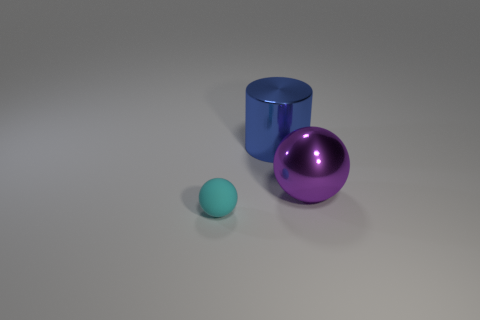Add 1 small matte objects. How many objects exist? 4 Subtract all spheres. How many objects are left? 1 Add 2 small spheres. How many small spheres exist? 3 Subtract 0 blue cubes. How many objects are left? 3 Subtract all large things. Subtract all large yellow metallic balls. How many objects are left? 1 Add 1 blue objects. How many blue objects are left? 2 